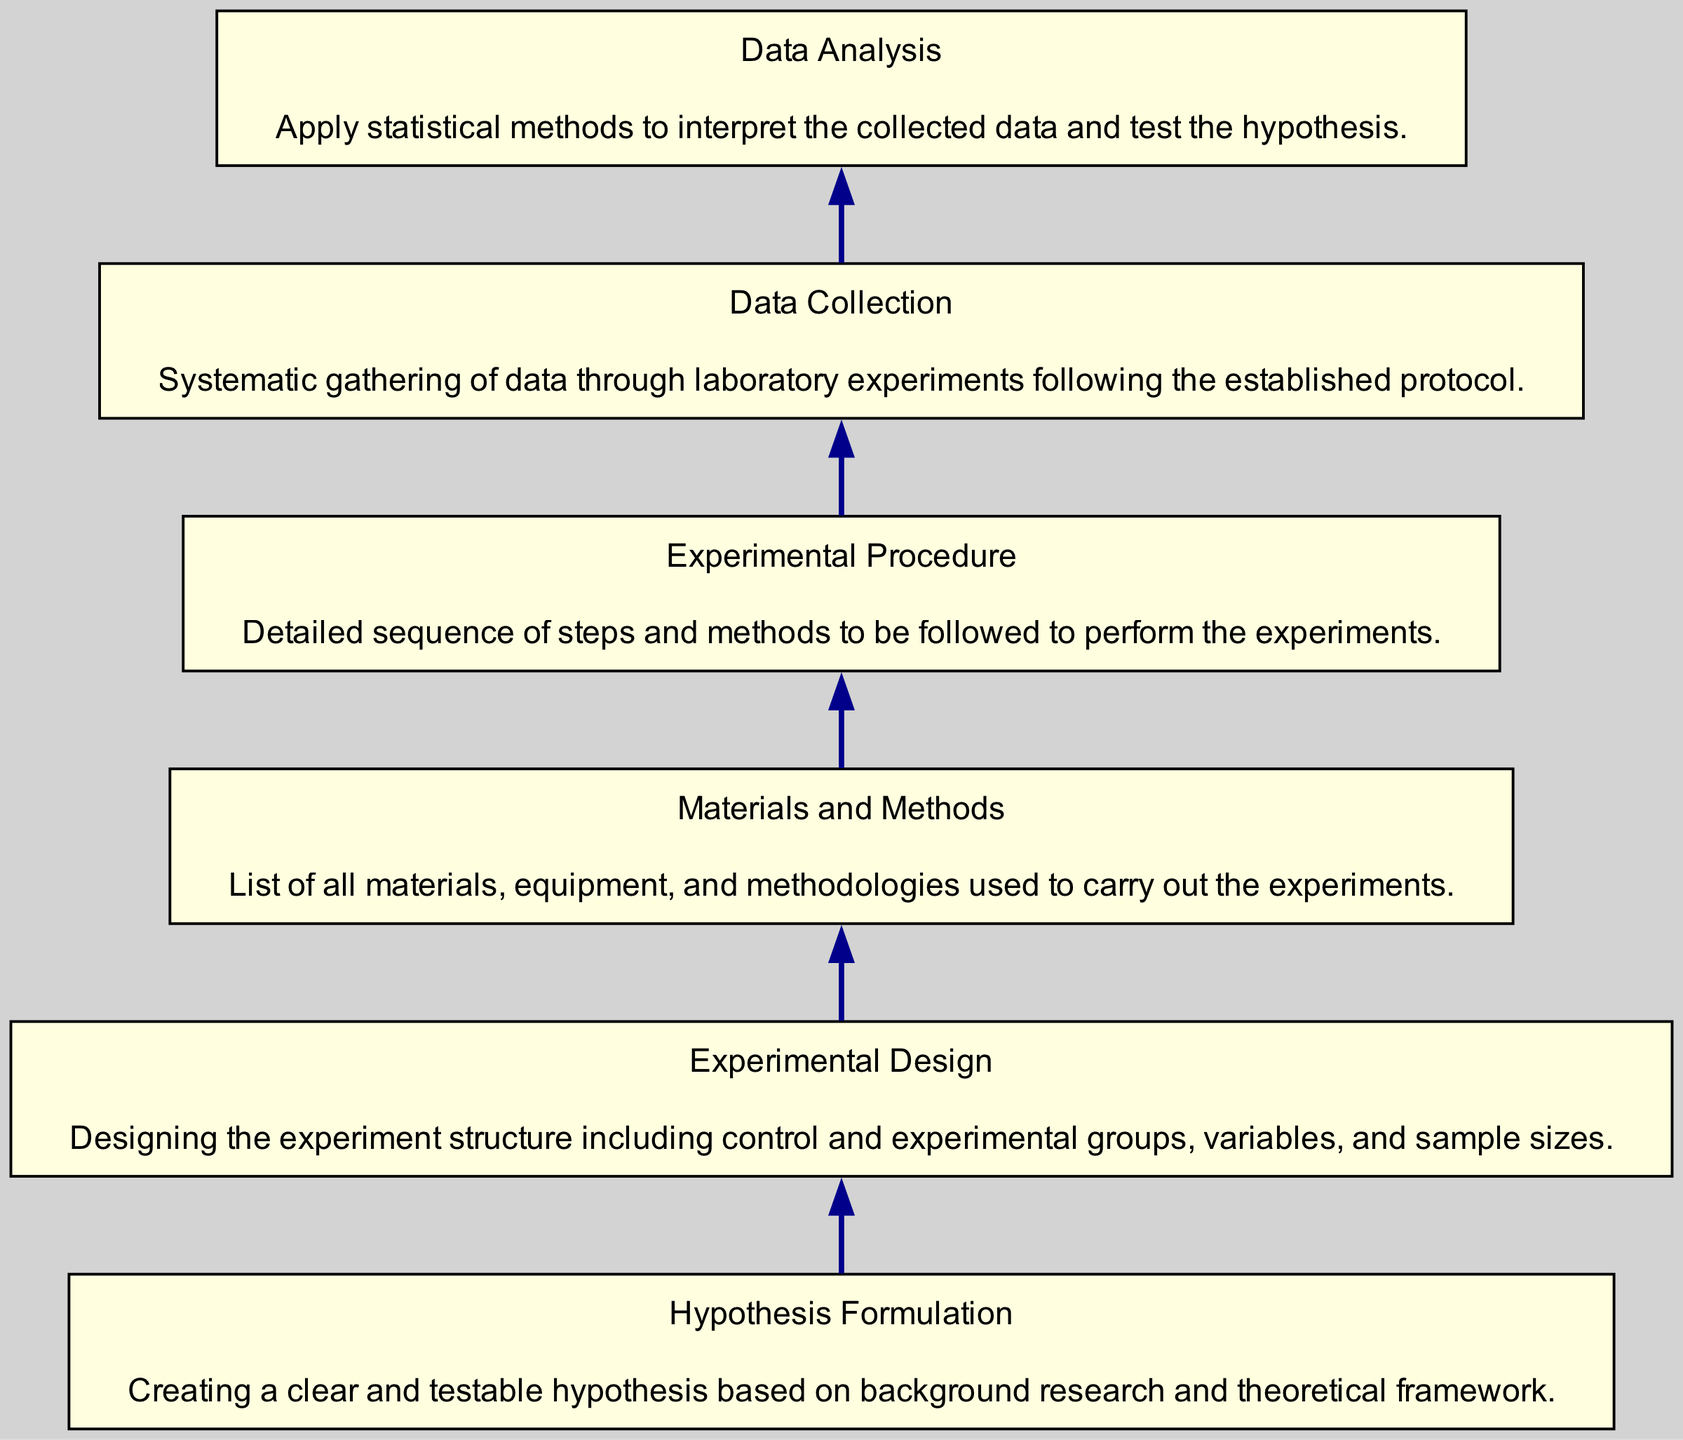What is the first step in the experimental procedure? The diagram indicates that the first step in the experimental procedure is 'Hypothesis Formulation'. This is at the bottom of the flow chart, representing the foundational step before any experimental activities.
Answer: Hypothesis Formulation How many nodes are in the diagram? The diagram contains six distinct nodes, each representing a different step in the experimental procedure from hypothesis formulation to data analysis.
Answer: Six What follows 'Materials and Methods' in the flow chart? According to the directional flow of the diagram, 'Data Collection' follows 'Materials and Methods'. This indicates that after establishing the materials and methods, the next step is to gather data through experiments.
Answer: Data Collection Which node describes the statistical methods applied to data? The 'Data Analysis' node describes the application of statistical methods used to interpret the collected data and test the hypothesis. This is placed at the top of the diagram, representing the final step of the procedure.
Answer: Data Analysis What is the relation between 'Experimental Design' and 'Data Collection'? 'Experimental Design' precedes 'Data Collection' in the flow chart, indicating that a well-structured design which includes variables and groups must be established before the actual collection of data takes place.
Answer: Precedes What is the last step of the experimental procedure? The last step, as indicated by the flow chart, is 'Data Analysis'. This is the final stage where statistical methods are applied to the previously collected data to interpret the results.
Answer: Data Analysis How does 'Experimental Procedure' relate to 'Hypothesis Formulation'? 'Experimental Procedure' follows 'Hypothesis Formulation' in the flow chart, indicating that once the hypothesis is established, a detailed sequence of steps must be formulated to carry out the experiments.
Answer: Follows 